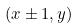<formula> <loc_0><loc_0><loc_500><loc_500>( x \pm 1 , y )</formula> 